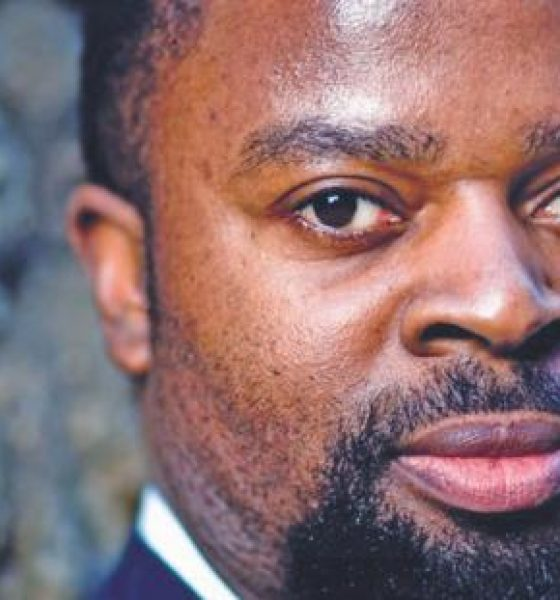Considering the attire of the individual and the professional quality of the photograph, what might be the possible context or event for which this photograph was taken? Based on the individual's attire—a dark suit and a light-colored shirt—and the professional quality of the photograph, the image likely represents a professional headshot. This type of photograph is commonly used for various professional purposes such as corporate profiles, company websites, academic presentations, press releases, or editorial features. The simplicity and focus on the individual's face suggest an intention to convey professionalism and credibility. The lack of distracting elements further emphasizes the importance of the subject's professional demeanor. 